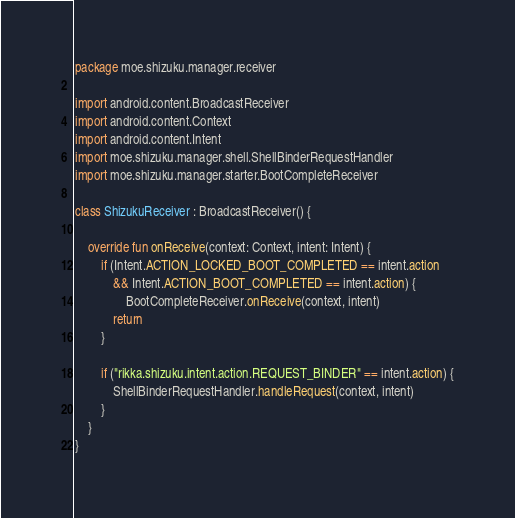Convert code to text. <code><loc_0><loc_0><loc_500><loc_500><_Kotlin_>package moe.shizuku.manager.receiver

import android.content.BroadcastReceiver
import android.content.Context
import android.content.Intent
import moe.shizuku.manager.shell.ShellBinderRequestHandler
import moe.shizuku.manager.starter.BootCompleteReceiver

class ShizukuReceiver : BroadcastReceiver() {

    override fun onReceive(context: Context, intent: Intent) {
        if (Intent.ACTION_LOCKED_BOOT_COMPLETED == intent.action
            && Intent.ACTION_BOOT_COMPLETED == intent.action) {
                BootCompleteReceiver.onReceive(context, intent)
            return
        }

        if ("rikka.shizuku.intent.action.REQUEST_BINDER" == intent.action) {
            ShellBinderRequestHandler.handleRequest(context, intent)
        }
    }
}
</code> 